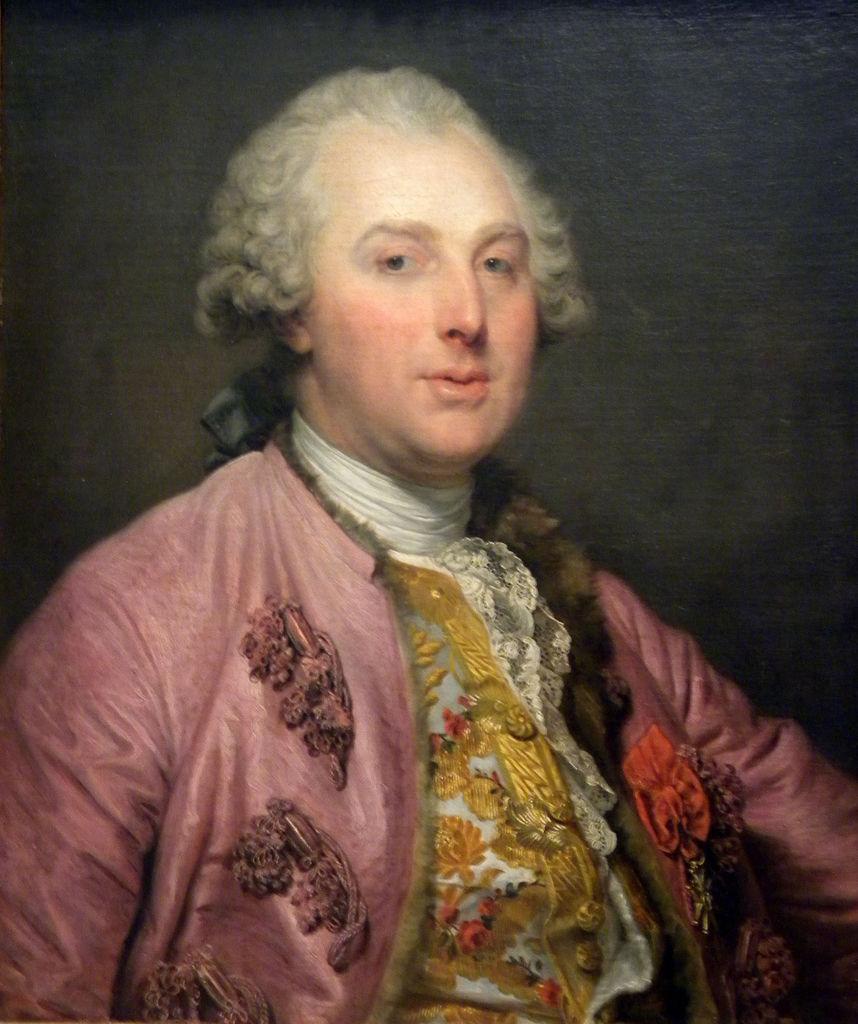Describe this image in one or two sentences. In this picture there is a person wearing colorful clothes and he is having curly hair. 